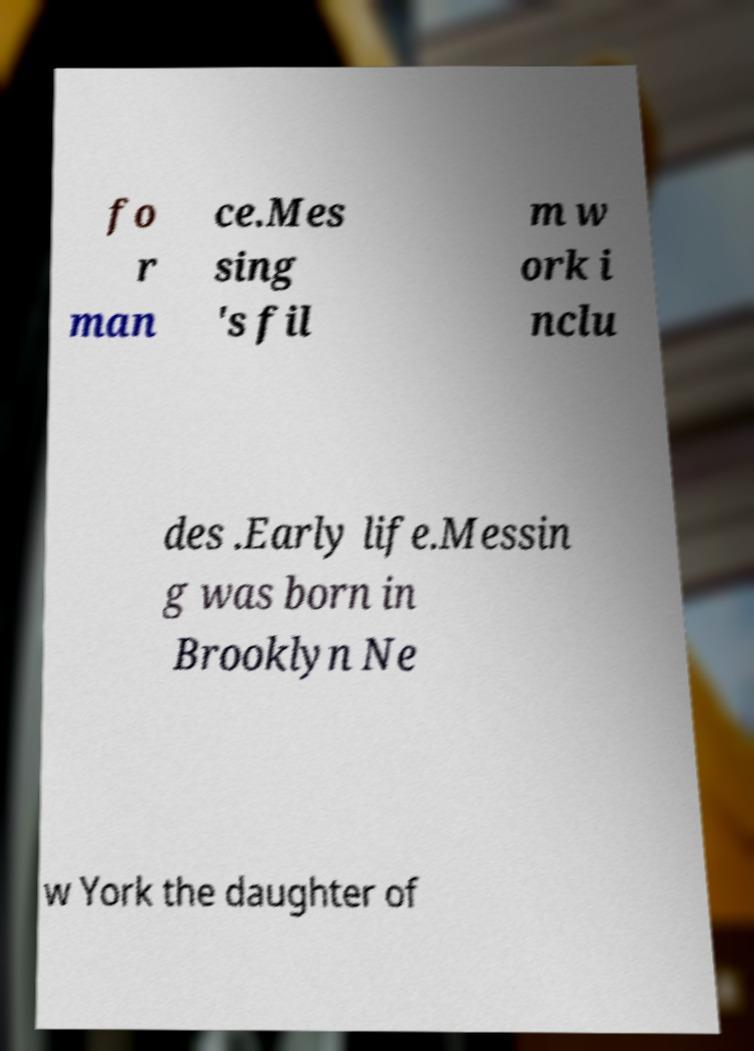For documentation purposes, I need the text within this image transcribed. Could you provide that? fo r man ce.Mes sing 's fil m w ork i nclu des .Early life.Messin g was born in Brooklyn Ne w York the daughter of 